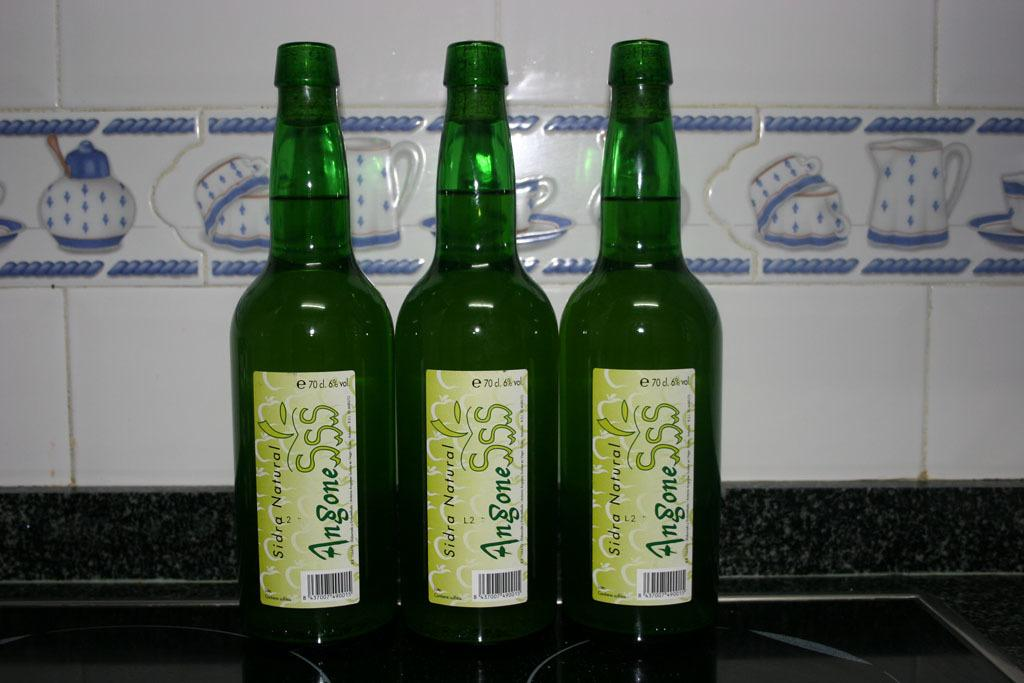Provide a one-sentence caption for the provided image. Three green bottles next to each other that say Sidra Natural. 